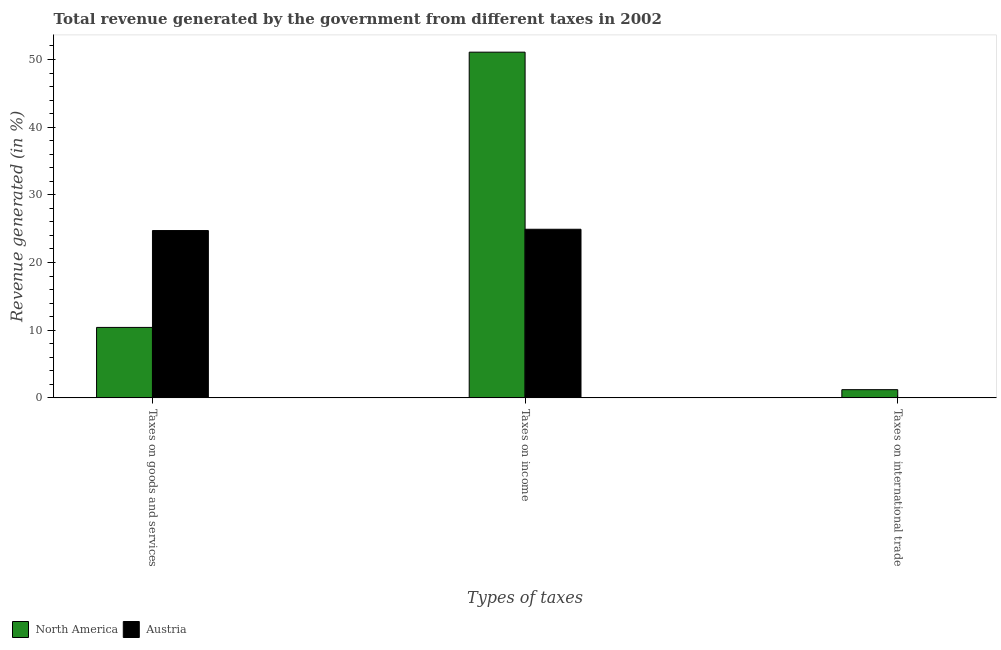How many different coloured bars are there?
Give a very brief answer. 2. How many bars are there on the 2nd tick from the right?
Your response must be concise. 2. What is the label of the 2nd group of bars from the left?
Give a very brief answer. Taxes on income. What is the percentage of revenue generated by taxes on goods and services in Austria?
Ensure brevity in your answer.  24.73. Across all countries, what is the maximum percentage of revenue generated by tax on international trade?
Your answer should be compact. 1.21. Across all countries, what is the minimum percentage of revenue generated by taxes on income?
Ensure brevity in your answer.  24.92. In which country was the percentage of revenue generated by tax on international trade maximum?
Give a very brief answer. North America. What is the total percentage of revenue generated by taxes on goods and services in the graph?
Keep it short and to the point. 35.14. What is the difference between the percentage of revenue generated by taxes on income in Austria and that in North America?
Offer a very short reply. -26.17. What is the difference between the percentage of revenue generated by taxes on income in Austria and the percentage of revenue generated by taxes on goods and services in North America?
Keep it short and to the point. 14.5. What is the average percentage of revenue generated by taxes on income per country?
Ensure brevity in your answer.  38. What is the difference between the percentage of revenue generated by taxes on income and percentage of revenue generated by taxes on goods and services in Austria?
Your answer should be compact. 0.19. In how many countries, is the percentage of revenue generated by tax on international trade greater than 4 %?
Ensure brevity in your answer.  0. What is the ratio of the percentage of revenue generated by taxes on goods and services in Austria to that in North America?
Ensure brevity in your answer.  2.37. What is the difference between the highest and the second highest percentage of revenue generated by taxes on income?
Give a very brief answer. 26.17. What is the difference between the highest and the lowest percentage of revenue generated by taxes on goods and services?
Make the answer very short. 14.31. In how many countries, is the percentage of revenue generated by taxes on goods and services greater than the average percentage of revenue generated by taxes on goods and services taken over all countries?
Your answer should be very brief. 1. Is the sum of the percentage of revenue generated by taxes on goods and services in North America and Austria greater than the maximum percentage of revenue generated by taxes on income across all countries?
Provide a short and direct response. No. How many bars are there?
Keep it short and to the point. 5. Are all the bars in the graph horizontal?
Keep it short and to the point. No. Are the values on the major ticks of Y-axis written in scientific E-notation?
Offer a terse response. No. Does the graph contain any zero values?
Offer a very short reply. Yes. Does the graph contain grids?
Offer a terse response. No. How many legend labels are there?
Your response must be concise. 2. What is the title of the graph?
Keep it short and to the point. Total revenue generated by the government from different taxes in 2002. What is the label or title of the X-axis?
Keep it short and to the point. Types of taxes. What is the label or title of the Y-axis?
Offer a terse response. Revenue generated (in %). What is the Revenue generated (in %) of North America in Taxes on goods and services?
Make the answer very short. 10.41. What is the Revenue generated (in %) in Austria in Taxes on goods and services?
Keep it short and to the point. 24.73. What is the Revenue generated (in %) in North America in Taxes on income?
Provide a succinct answer. 51.09. What is the Revenue generated (in %) of Austria in Taxes on income?
Give a very brief answer. 24.92. What is the Revenue generated (in %) of North America in Taxes on international trade?
Provide a succinct answer. 1.21. What is the Revenue generated (in %) in Austria in Taxes on international trade?
Your answer should be compact. 0. Across all Types of taxes, what is the maximum Revenue generated (in %) in North America?
Provide a succinct answer. 51.09. Across all Types of taxes, what is the maximum Revenue generated (in %) of Austria?
Your response must be concise. 24.92. Across all Types of taxes, what is the minimum Revenue generated (in %) in North America?
Offer a terse response. 1.21. What is the total Revenue generated (in %) in North America in the graph?
Provide a succinct answer. 62.71. What is the total Revenue generated (in %) of Austria in the graph?
Your answer should be compact. 49.64. What is the difference between the Revenue generated (in %) in North America in Taxes on goods and services and that in Taxes on income?
Your answer should be compact. -40.68. What is the difference between the Revenue generated (in %) of Austria in Taxes on goods and services and that in Taxes on income?
Your response must be concise. -0.19. What is the difference between the Revenue generated (in %) in North America in Taxes on goods and services and that in Taxes on international trade?
Your answer should be compact. 9.2. What is the difference between the Revenue generated (in %) in North America in Taxes on income and that in Taxes on international trade?
Ensure brevity in your answer.  49.88. What is the difference between the Revenue generated (in %) of North America in Taxes on goods and services and the Revenue generated (in %) of Austria in Taxes on income?
Offer a terse response. -14.5. What is the average Revenue generated (in %) in North America per Types of taxes?
Provide a short and direct response. 20.9. What is the average Revenue generated (in %) in Austria per Types of taxes?
Give a very brief answer. 16.55. What is the difference between the Revenue generated (in %) in North America and Revenue generated (in %) in Austria in Taxes on goods and services?
Offer a very short reply. -14.31. What is the difference between the Revenue generated (in %) of North America and Revenue generated (in %) of Austria in Taxes on income?
Provide a short and direct response. 26.17. What is the ratio of the Revenue generated (in %) in North America in Taxes on goods and services to that in Taxes on income?
Your answer should be very brief. 0.2. What is the ratio of the Revenue generated (in %) of North America in Taxes on goods and services to that in Taxes on international trade?
Make the answer very short. 8.59. What is the ratio of the Revenue generated (in %) of North America in Taxes on income to that in Taxes on international trade?
Your response must be concise. 42.17. What is the difference between the highest and the second highest Revenue generated (in %) of North America?
Offer a very short reply. 40.68. What is the difference between the highest and the lowest Revenue generated (in %) in North America?
Provide a short and direct response. 49.88. What is the difference between the highest and the lowest Revenue generated (in %) of Austria?
Your answer should be compact. 24.92. 